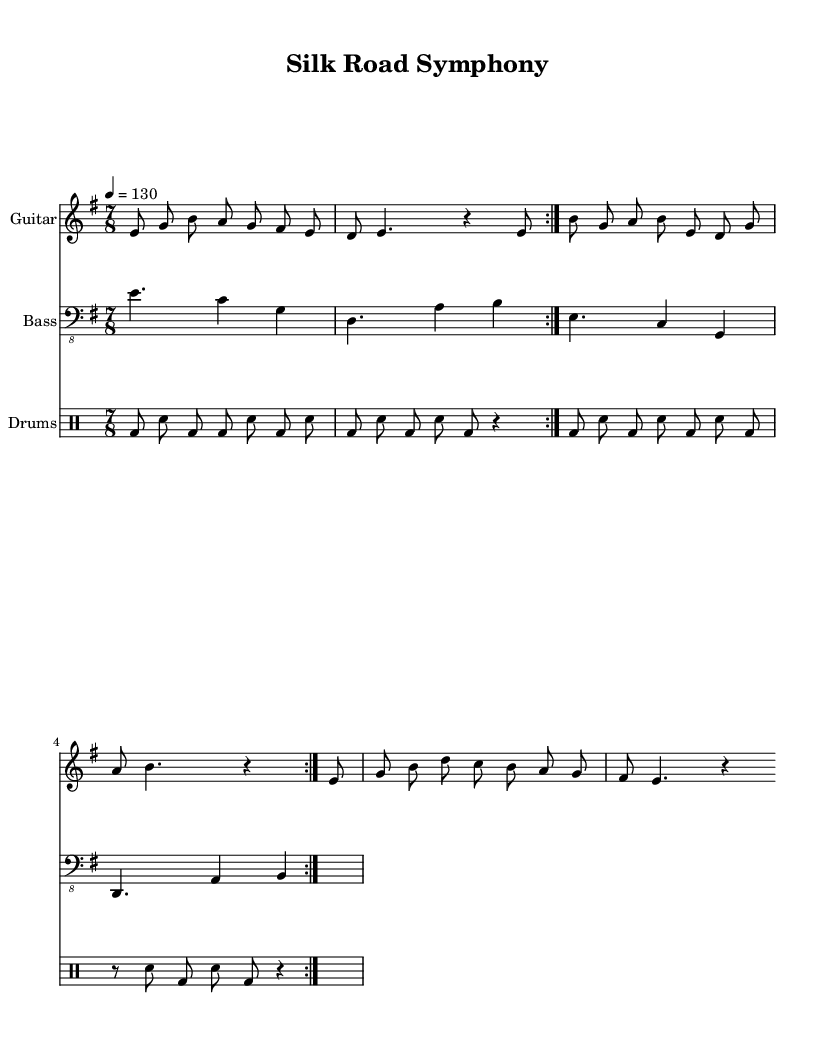What is the key signature of this music? The key signature is E minor, which has one sharp (F#). You can determine the key signature by looking at the sharp sign positioned on the staff, indicating the presence of F#.
Answer: E minor What is the time signature of this music? The time signature is 7/8, which can be found at the beginning of the score. It indicates that there are seven eighth notes in each measure.
Answer: 7/8 What is the tempo indication for this music? The tempo is set at a quarter note equals 130 beats per minute, as indicated at the start of the sheet music. This tells the musicians how fast to play.
Answer: 130 How many times is the main section repeated? The main section is indicated to be repeated twice with the use of the "volta" markings. This suggests the same musical passage is played two times.
Answer: 2 Which instruments are included in this score? The instruments listed in the score are Guitar, Bass, and Drums. Each instrument has its own dedicated staff in the score.
Answer: Guitar, Bass, Drums What is the rhythmic feel of the drum section? The drum section features a consistent alternating pattern of bass drums and snare hits, typical of many metal compositions, characterized by a driving and aggressive rhythm. This can be discerned from the drum notation in the music.
Answer: Aggressive 